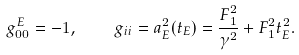<formula> <loc_0><loc_0><loc_500><loc_500>g _ { 0 0 } ^ { E } = - 1 , \quad g _ { i i } = a _ { E } ^ { 2 } ( t _ { E } ) = \frac { F _ { 1 } ^ { 2 } } { \gamma ^ { 2 } } + F _ { 1 } ^ { 2 } t _ { E } ^ { 2 } .</formula> 